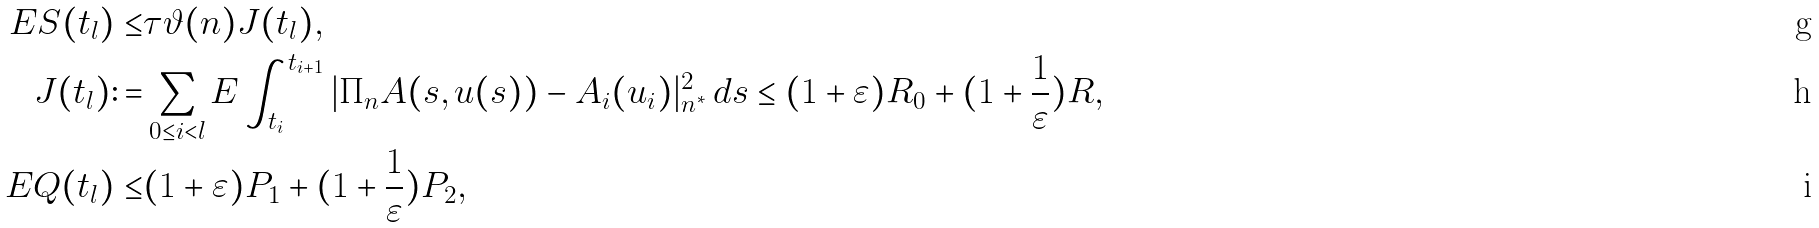<formula> <loc_0><loc_0><loc_500><loc_500>E S ( t _ { l } ) \leq & \tau \vartheta ( n ) J ( t _ { l } ) , \\ J ( t _ { l } ) \colon = & \sum _ { 0 \leq i < l } E \int _ { t _ { i } } ^ { t _ { i + 1 } } | \Pi _ { n } A ( s , u ( s ) ) - A _ { i } ( u _ { i } ) | _ { n ^ { \ast } } ^ { 2 } \, d s \leq ( 1 + \varepsilon ) R _ { 0 } + ( 1 + \frac { 1 } { \varepsilon } ) R , \\ E Q ( t _ { l } ) \leq & ( 1 + \varepsilon ) P _ { 1 } + ( 1 + \frac { 1 } { \varepsilon } ) P _ { 2 } ,</formula> 